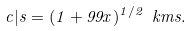<formula> <loc_0><loc_0><loc_500><loc_500>c | s = ( 1 + 9 9 x ) ^ { 1 / 2 } \ k m s .</formula> 